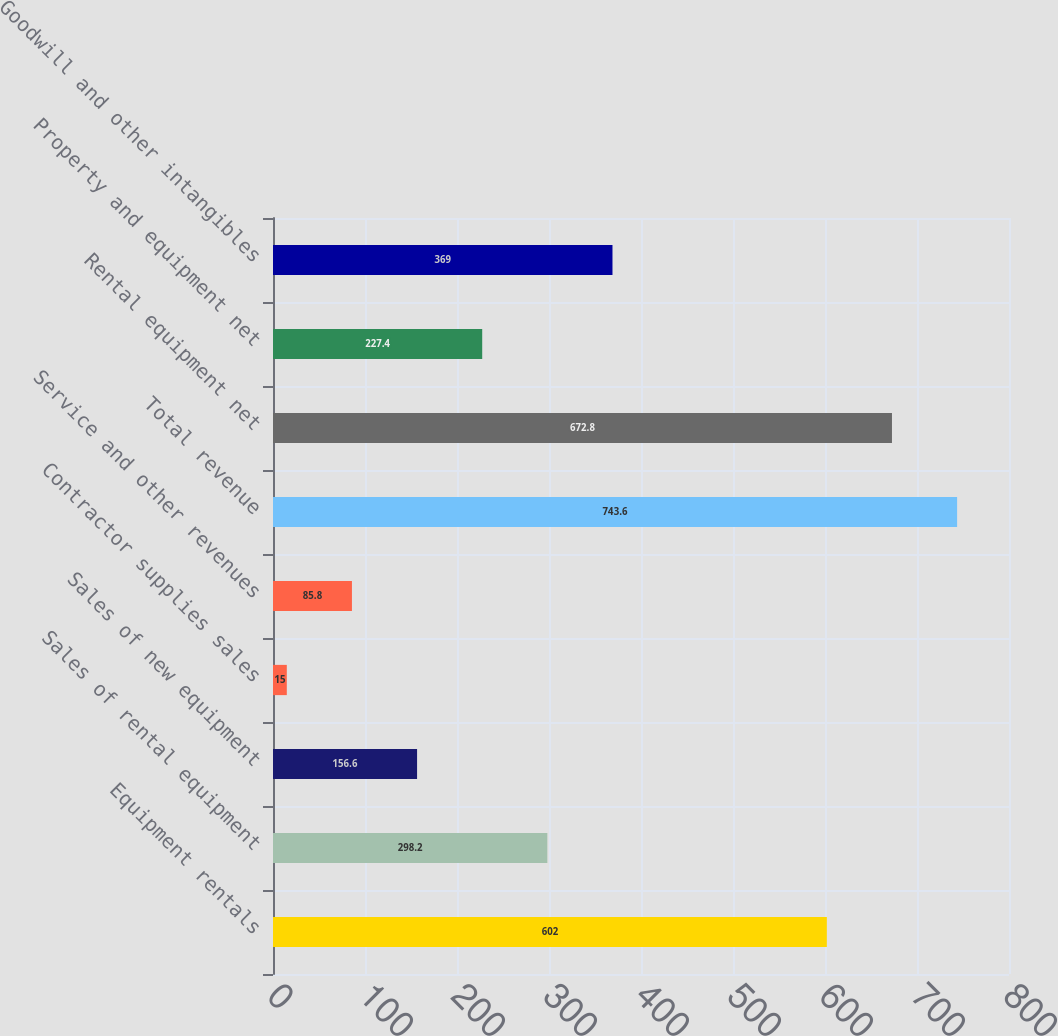Convert chart to OTSL. <chart><loc_0><loc_0><loc_500><loc_500><bar_chart><fcel>Equipment rentals<fcel>Sales of rental equipment<fcel>Sales of new equipment<fcel>Contractor supplies sales<fcel>Service and other revenues<fcel>Total revenue<fcel>Rental equipment net<fcel>Property and equipment net<fcel>Goodwill and other intangibles<nl><fcel>602<fcel>298.2<fcel>156.6<fcel>15<fcel>85.8<fcel>743.6<fcel>672.8<fcel>227.4<fcel>369<nl></chart> 